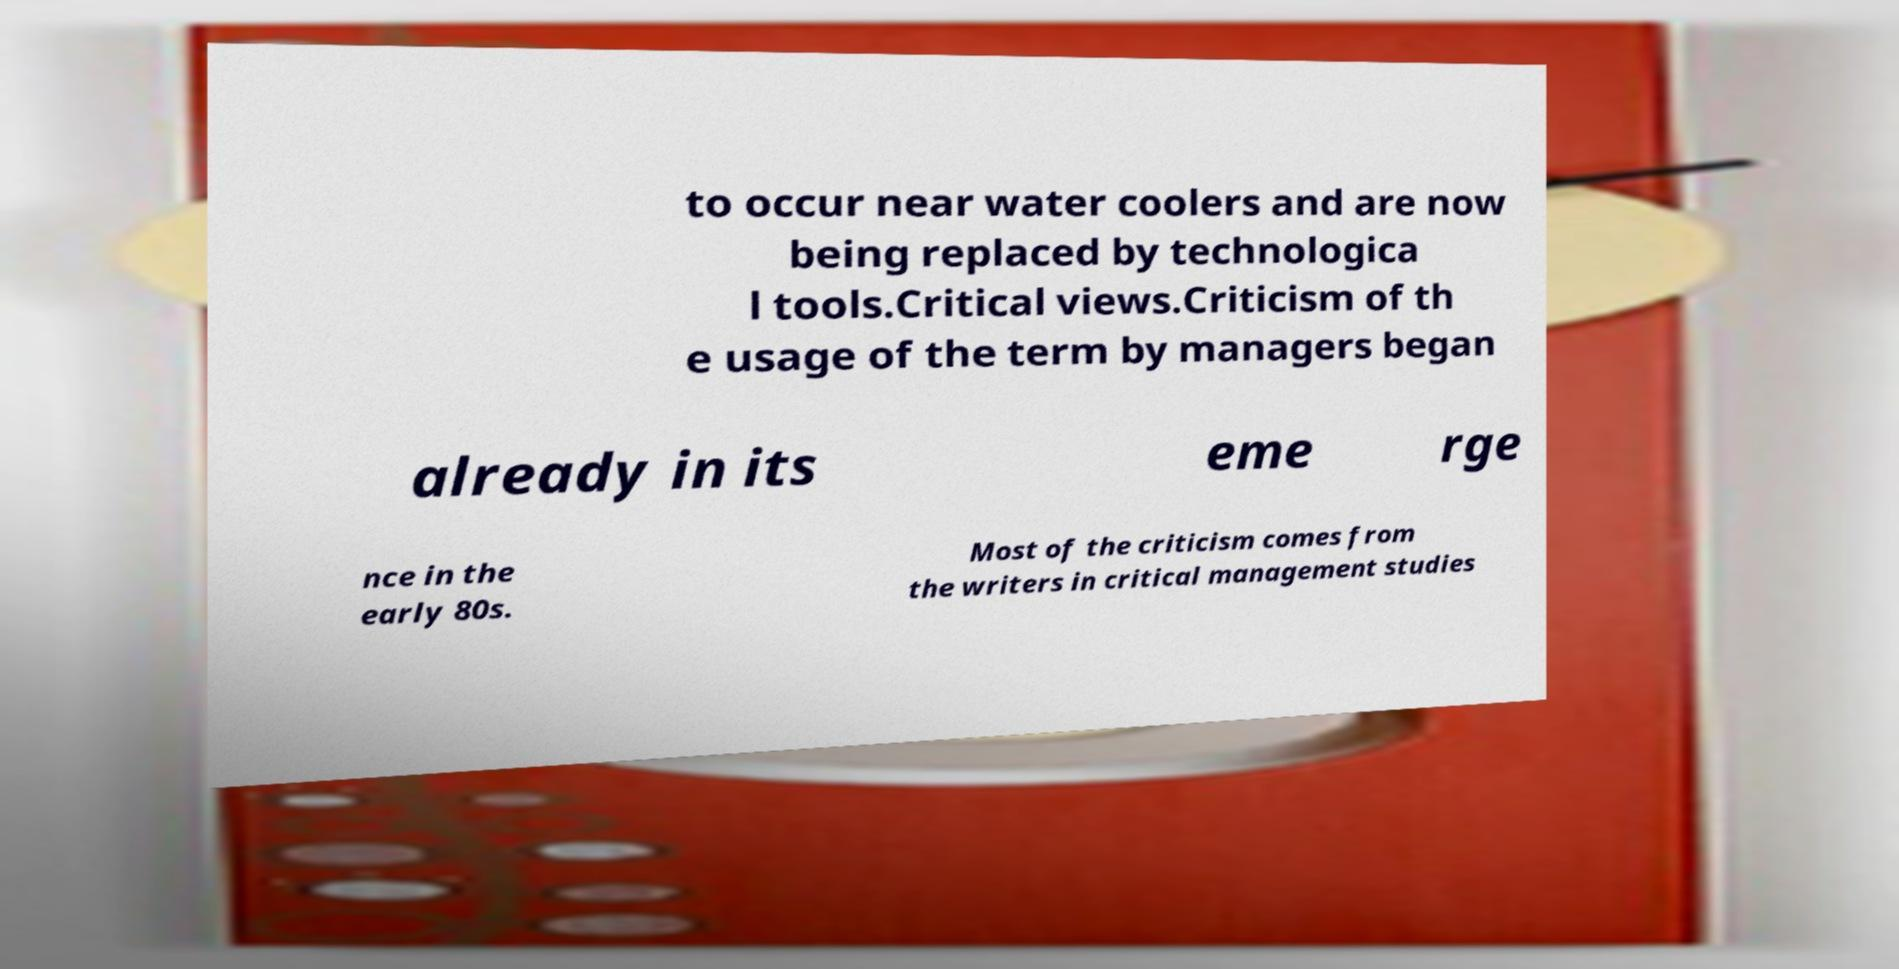There's text embedded in this image that I need extracted. Can you transcribe it verbatim? to occur near water coolers and are now being replaced by technologica l tools.Critical views.Criticism of th e usage of the term by managers began already in its eme rge nce in the early 80s. Most of the criticism comes from the writers in critical management studies 